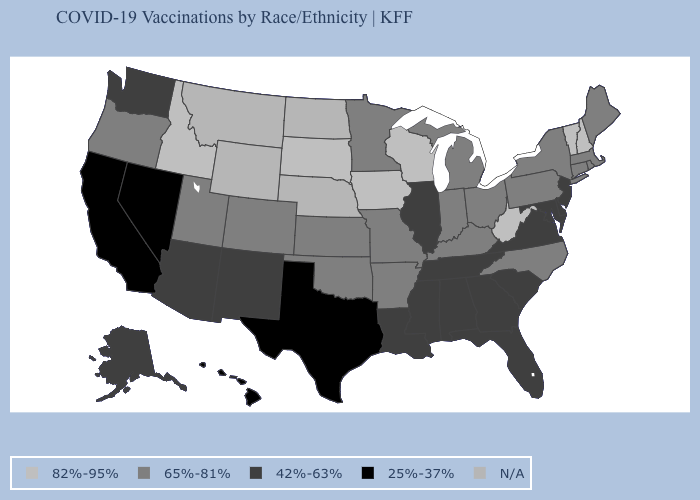Which states hav the highest value in the South?
Keep it brief. West Virginia. What is the lowest value in the USA?
Give a very brief answer. 25%-37%. Is the legend a continuous bar?
Be succinct. No. What is the value of Texas?
Answer briefly. 25%-37%. What is the lowest value in states that border Kentucky?
Short answer required. 42%-63%. Does the map have missing data?
Answer briefly. Yes. Does West Virginia have the highest value in the South?
Write a very short answer. Yes. Is the legend a continuous bar?
Write a very short answer. No. What is the value of Iowa?
Answer briefly. 82%-95%. Name the states that have a value in the range 25%-37%?
Short answer required. California, Hawaii, Nevada, Texas. What is the value of Hawaii?
Write a very short answer. 25%-37%. Name the states that have a value in the range 65%-81%?
Write a very short answer. Arkansas, Colorado, Connecticut, Indiana, Kansas, Kentucky, Maine, Massachusetts, Michigan, Minnesota, Missouri, New York, North Carolina, Ohio, Oklahoma, Oregon, Pennsylvania, Rhode Island, Utah. What is the value of Florida?
Answer briefly. 42%-63%. 